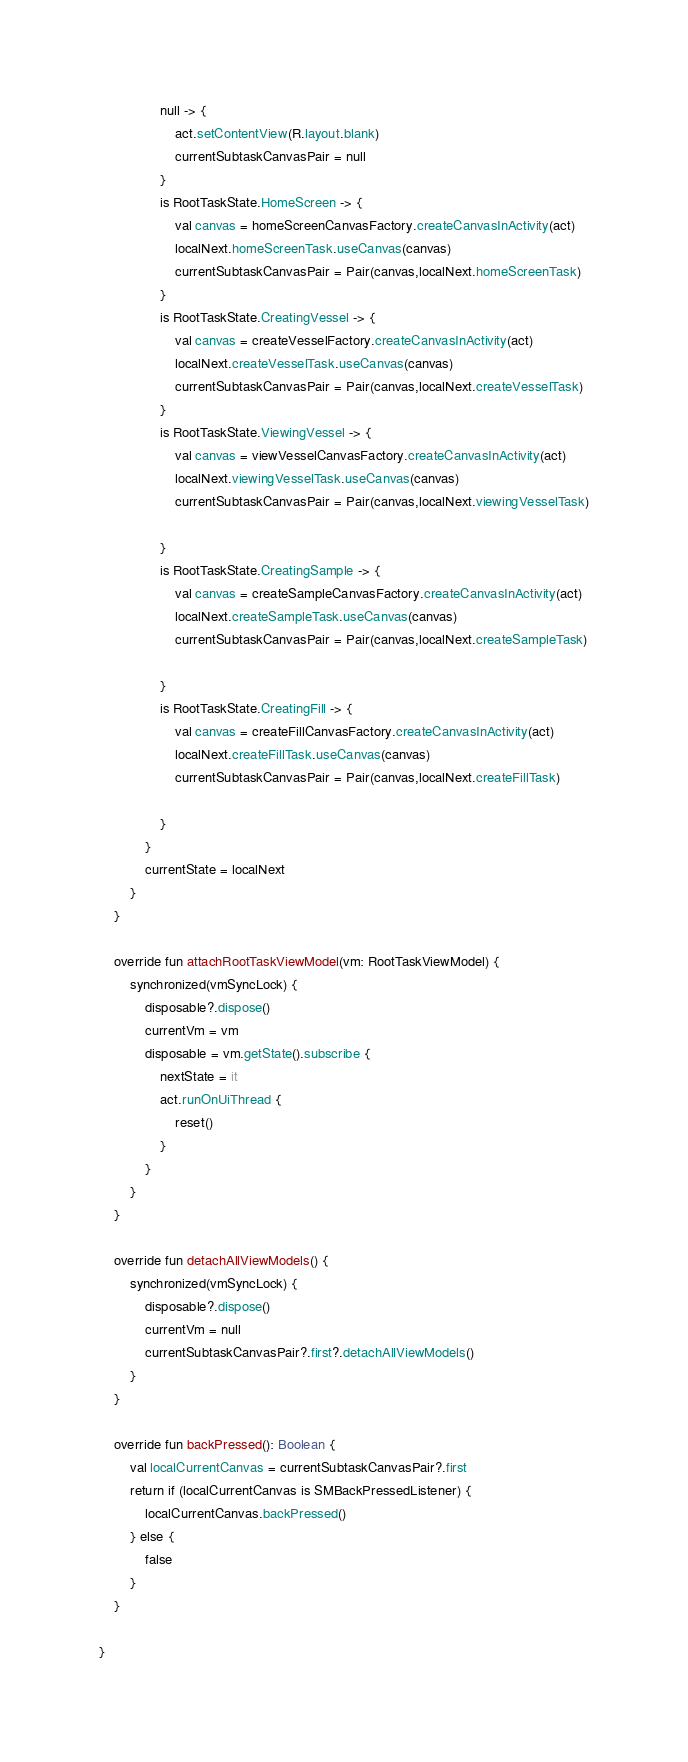Convert code to text. <code><loc_0><loc_0><loc_500><loc_500><_Kotlin_>                null -> {
                    act.setContentView(R.layout.blank)
                    currentSubtaskCanvasPair = null
                }
                is RootTaskState.HomeScreen -> {
                    val canvas = homeScreenCanvasFactory.createCanvasInActivity(act)
                    localNext.homeScreenTask.useCanvas(canvas)
                    currentSubtaskCanvasPair = Pair(canvas,localNext.homeScreenTask)
                }
                is RootTaskState.CreatingVessel -> {
                    val canvas = createVesselFactory.createCanvasInActivity(act)
                    localNext.createVesselTask.useCanvas(canvas)
                    currentSubtaskCanvasPair = Pair(canvas,localNext.createVesselTask)
                }
                is RootTaskState.ViewingVessel -> {
                    val canvas = viewVesselCanvasFactory.createCanvasInActivity(act)
                    localNext.viewingVesselTask.useCanvas(canvas)
                    currentSubtaskCanvasPair = Pair(canvas,localNext.viewingVesselTask)

                }
                is RootTaskState.CreatingSample -> {
                    val canvas = createSampleCanvasFactory.createCanvasInActivity(act)
                    localNext.createSampleTask.useCanvas(canvas)
                    currentSubtaskCanvasPair = Pair(canvas,localNext.createSampleTask)

                }
                is RootTaskState.CreatingFill -> {
                    val canvas = createFillCanvasFactory.createCanvasInActivity(act)
                    localNext.createFillTask.useCanvas(canvas)
                    currentSubtaskCanvasPair = Pair(canvas,localNext.createFillTask)

                }
            }
            currentState = localNext
        }
    }

    override fun attachRootTaskViewModel(vm: RootTaskViewModel) {
        synchronized(vmSyncLock) {
            disposable?.dispose()
            currentVm = vm
            disposable = vm.getState().subscribe {
                nextState = it
                act.runOnUiThread {
                    reset()
                }
            }
        }
    }

    override fun detachAllViewModels() {
        synchronized(vmSyncLock) {
            disposable?.dispose()
            currentVm = null
            currentSubtaskCanvasPair?.first?.detachAllViewModels()
        }
    }

    override fun backPressed(): Boolean {
        val localCurrentCanvas = currentSubtaskCanvasPair?.first
        return if (localCurrentCanvas is SMBackPressedListener) {
            localCurrentCanvas.backPressed()
        } else {
            false
        }
    }

}</code> 